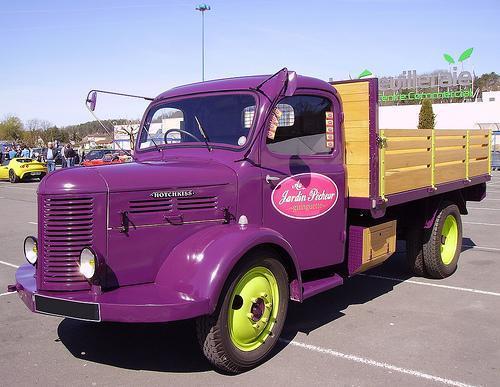How many trucks are in this picture?
Give a very brief answer. 1. How many headlights does the truck have?
Give a very brief answer. 2. How many lights are in front of the truck?
Give a very brief answer. 2. How many tires are on the truck?
Give a very brief answer. 6. 